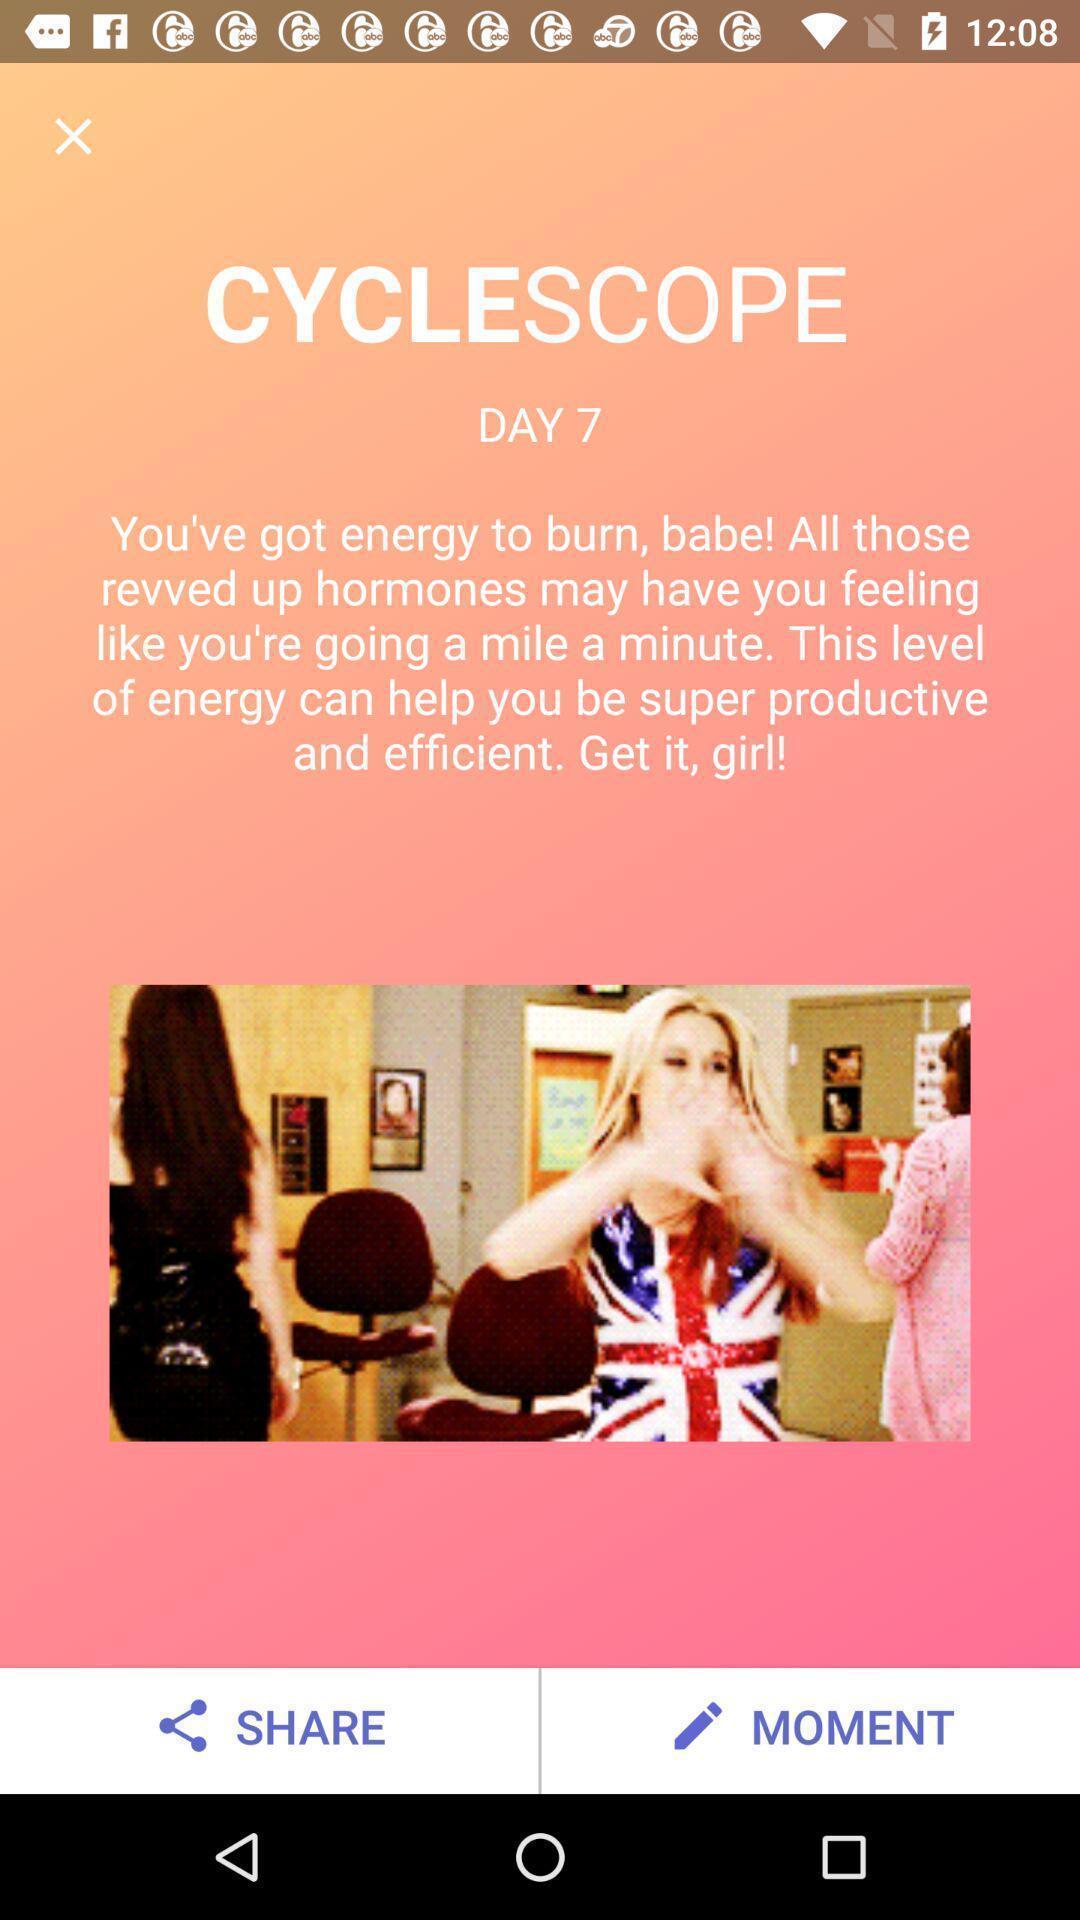Provide a textual representation of this image. Start page of menstrual app. 